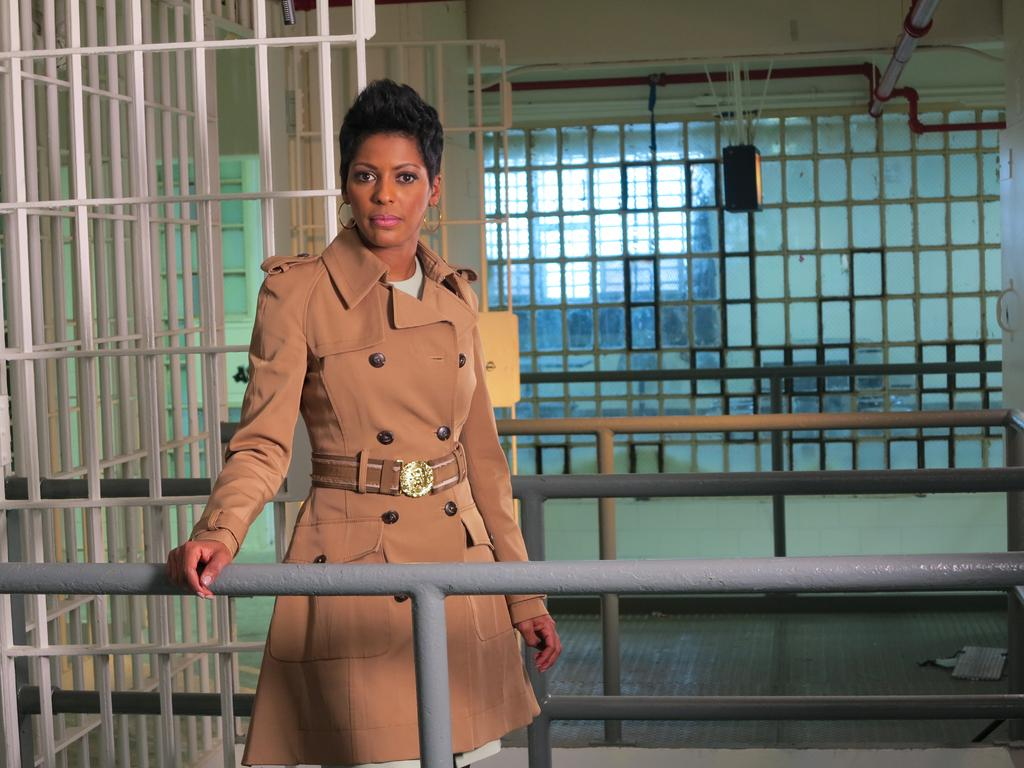Who is present in the image? There is a woman in the image. What is the woman doing in the image? The woman is standing in the image. What is the woman wearing in the image? The woman is wearing a coat in the image. What objects can be seen in the background or surrounding the woman? There are iron rods or poles visible in the image. What type of vase is placed on the iron rods in the image? There is no vase present in the image; only the woman and iron rods or poles are visible. 